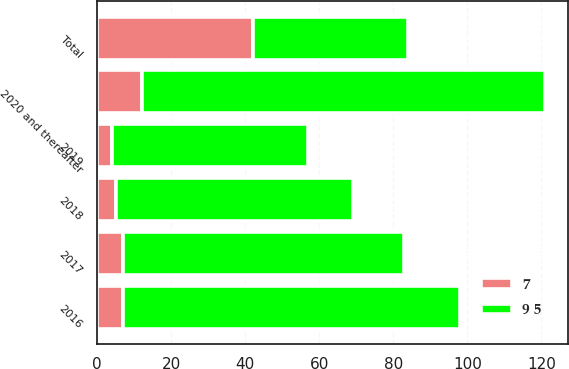Convert chart. <chart><loc_0><loc_0><loc_500><loc_500><stacked_bar_chart><ecel><fcel>2016<fcel>2017<fcel>2018<fcel>2019<fcel>2020 and thereafter<fcel>Total<nl><fcel>9 5<fcel>91<fcel>76<fcel>64<fcel>53<fcel>109<fcel>42<nl><fcel>7<fcel>7<fcel>7<fcel>5<fcel>4<fcel>12<fcel>42<nl></chart> 